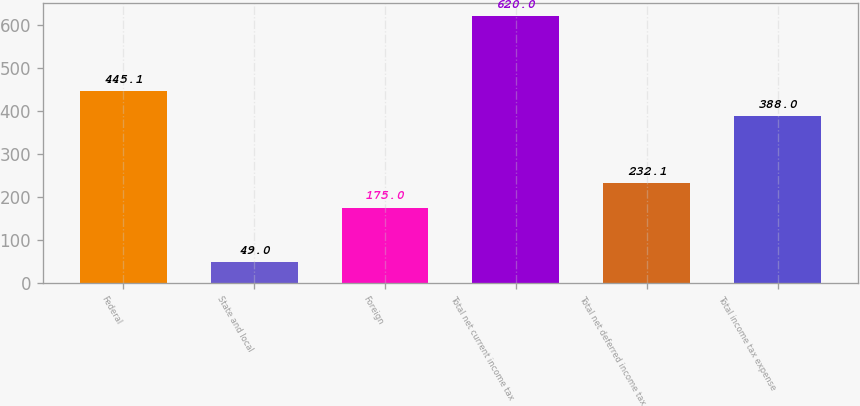Convert chart. <chart><loc_0><loc_0><loc_500><loc_500><bar_chart><fcel>Federal<fcel>State and local<fcel>Foreign<fcel>Total net current income tax<fcel>Total net deferred income tax<fcel>Total income tax expense<nl><fcel>445.1<fcel>49<fcel>175<fcel>620<fcel>232.1<fcel>388<nl></chart> 